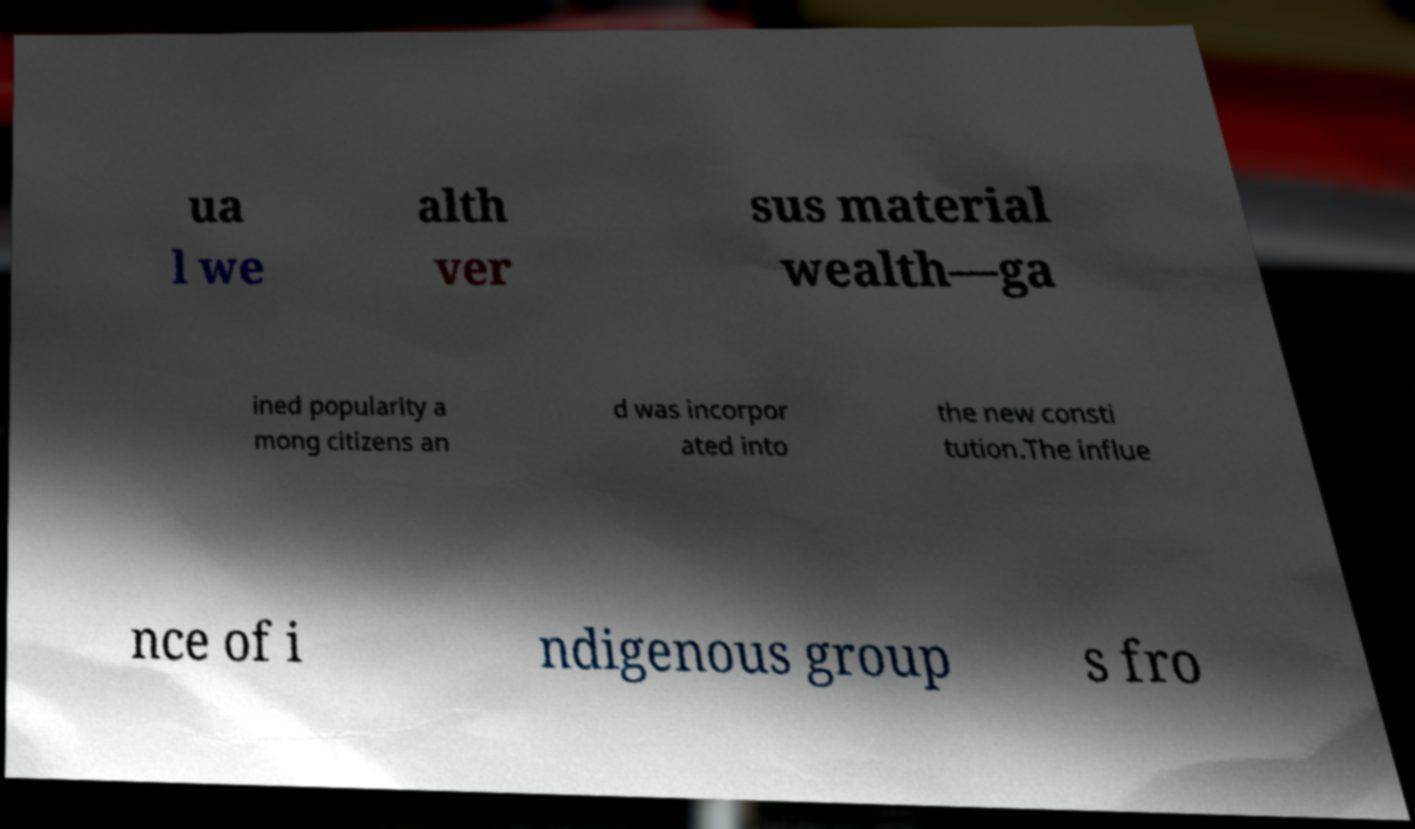I need the written content from this picture converted into text. Can you do that? ua l we alth ver sus material wealth—ga ined popularity a mong citizens an d was incorpor ated into the new consti tution.The influe nce of i ndigenous group s fro 